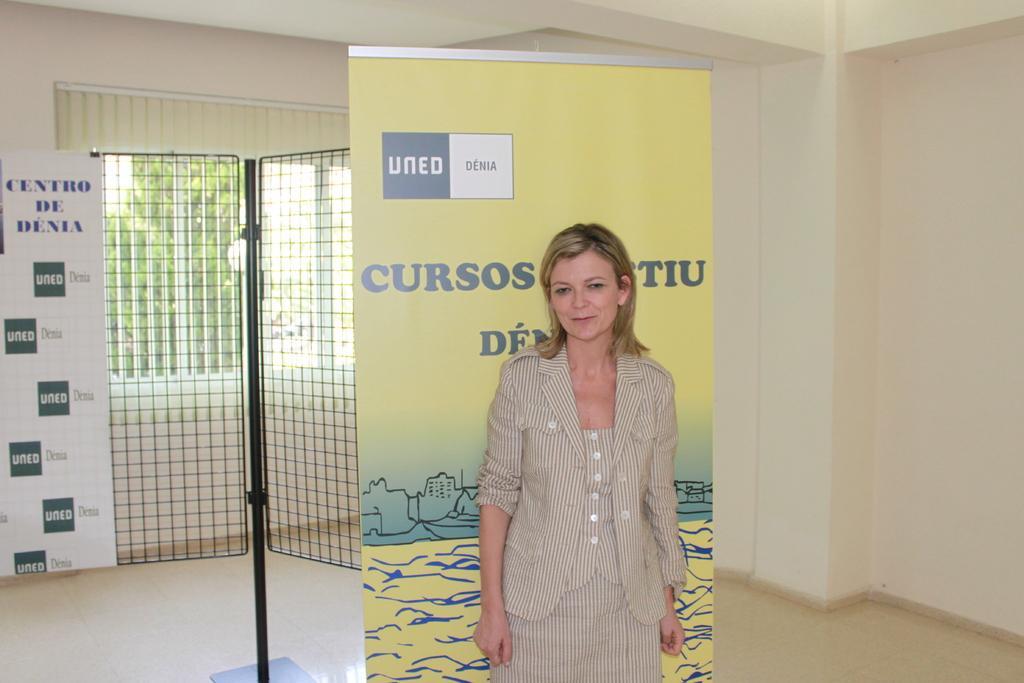Can you describe this image briefly? In this image we can see a lady and a board. In the background of the image there is a board, rod with grille, wall and other objects. At the top of the image there is the ceiling. 